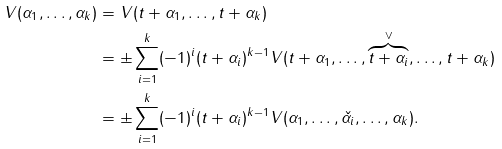<formula> <loc_0><loc_0><loc_500><loc_500>V ( \alpha _ { 1 } , \dots , \alpha _ { k } ) & = V ( t + \alpha _ { 1 } , \dots , t + \alpha _ { k } ) \\ & = \pm \sum _ { i = 1 } ^ { k } ( - 1 ) ^ { i } ( t + \alpha _ { i } ) ^ { k - 1 } V ( t + \alpha _ { 1 } , \dots , { \overbrace { t + \alpha _ { i } } ^ { \vee } } , \dots , t + \alpha _ { k } ) \\ & = \pm \sum _ { i = 1 } ^ { k } ( - 1 ) ^ { i } ( t + \alpha _ { i } ) ^ { k - 1 } V ( \alpha _ { 1 } , \dots , \check { \alpha _ { i } } , \dots , \alpha _ { k } ) . \\</formula> 